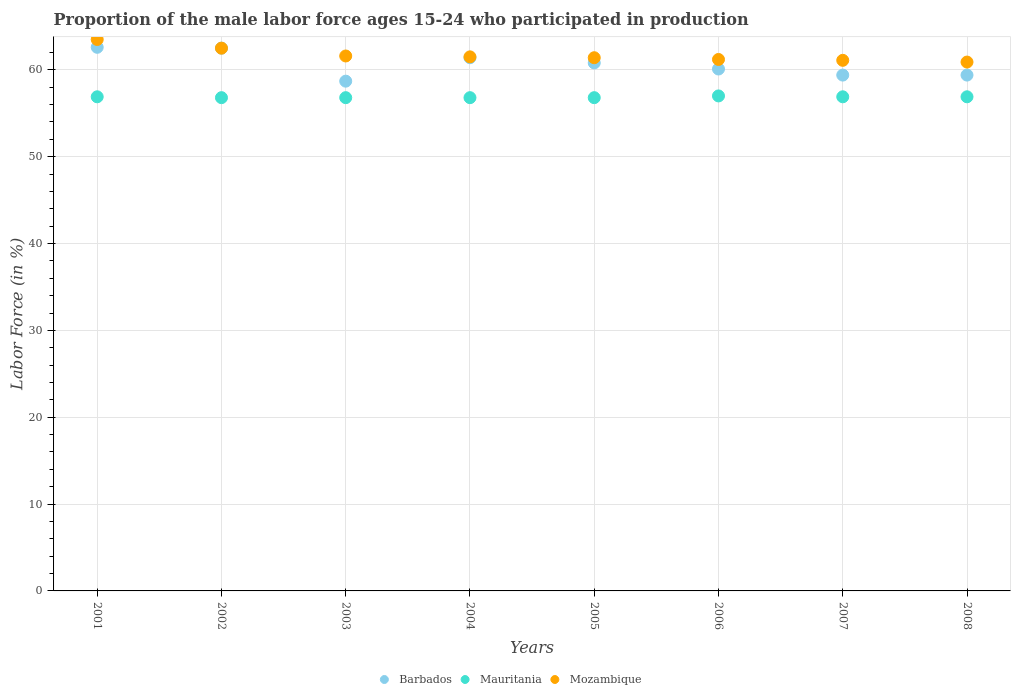Is the number of dotlines equal to the number of legend labels?
Give a very brief answer. Yes. What is the proportion of the male labor force who participated in production in Barbados in 2002?
Offer a very short reply. 62.5. Across all years, what is the maximum proportion of the male labor force who participated in production in Mauritania?
Offer a very short reply. 57. Across all years, what is the minimum proportion of the male labor force who participated in production in Barbados?
Your answer should be compact. 58.7. In which year was the proportion of the male labor force who participated in production in Mozambique maximum?
Provide a succinct answer. 2001. In which year was the proportion of the male labor force who participated in production in Mozambique minimum?
Your answer should be compact. 2008. What is the total proportion of the male labor force who participated in production in Barbados in the graph?
Give a very brief answer. 484.9. What is the difference between the proportion of the male labor force who participated in production in Mauritania in 2003 and that in 2008?
Keep it short and to the point. -0.1. What is the difference between the proportion of the male labor force who participated in production in Mozambique in 2004 and the proportion of the male labor force who participated in production in Mauritania in 2008?
Give a very brief answer. 4.6. What is the average proportion of the male labor force who participated in production in Mauritania per year?
Give a very brief answer. 56.86. In the year 2008, what is the difference between the proportion of the male labor force who participated in production in Barbados and proportion of the male labor force who participated in production in Mauritania?
Provide a short and direct response. 2.5. In how many years, is the proportion of the male labor force who participated in production in Barbados greater than 48 %?
Your answer should be very brief. 8. What is the ratio of the proportion of the male labor force who participated in production in Barbados in 2004 to that in 2006?
Your answer should be very brief. 1.02. Is the proportion of the male labor force who participated in production in Mozambique in 2001 less than that in 2006?
Your answer should be compact. No. Is the difference between the proportion of the male labor force who participated in production in Barbados in 2005 and 2006 greater than the difference between the proportion of the male labor force who participated in production in Mauritania in 2005 and 2006?
Make the answer very short. Yes. What is the difference between the highest and the lowest proportion of the male labor force who participated in production in Barbados?
Your answer should be very brief. 3.9. In how many years, is the proportion of the male labor force who participated in production in Barbados greater than the average proportion of the male labor force who participated in production in Barbados taken over all years?
Your answer should be very brief. 4. Is the sum of the proportion of the male labor force who participated in production in Mozambique in 2002 and 2004 greater than the maximum proportion of the male labor force who participated in production in Barbados across all years?
Make the answer very short. Yes. Is it the case that in every year, the sum of the proportion of the male labor force who participated in production in Mauritania and proportion of the male labor force who participated in production in Mozambique  is greater than the proportion of the male labor force who participated in production in Barbados?
Keep it short and to the point. Yes. Does the proportion of the male labor force who participated in production in Mozambique monotonically increase over the years?
Ensure brevity in your answer.  No. Is the proportion of the male labor force who participated in production in Mauritania strictly less than the proportion of the male labor force who participated in production in Mozambique over the years?
Offer a very short reply. Yes. How many dotlines are there?
Make the answer very short. 3. How many years are there in the graph?
Provide a succinct answer. 8. What is the difference between two consecutive major ticks on the Y-axis?
Provide a succinct answer. 10. Are the values on the major ticks of Y-axis written in scientific E-notation?
Keep it short and to the point. No. Where does the legend appear in the graph?
Give a very brief answer. Bottom center. How many legend labels are there?
Ensure brevity in your answer.  3. What is the title of the graph?
Offer a very short reply. Proportion of the male labor force ages 15-24 who participated in production. Does "Eritrea" appear as one of the legend labels in the graph?
Give a very brief answer. No. What is the label or title of the X-axis?
Keep it short and to the point. Years. What is the label or title of the Y-axis?
Offer a very short reply. Labor Force (in %). What is the Labor Force (in %) of Barbados in 2001?
Offer a terse response. 62.6. What is the Labor Force (in %) in Mauritania in 2001?
Your answer should be very brief. 56.9. What is the Labor Force (in %) of Mozambique in 2001?
Your answer should be very brief. 63.5. What is the Labor Force (in %) of Barbados in 2002?
Ensure brevity in your answer.  62.5. What is the Labor Force (in %) in Mauritania in 2002?
Provide a short and direct response. 56.8. What is the Labor Force (in %) of Mozambique in 2002?
Provide a succinct answer. 62.5. What is the Labor Force (in %) in Barbados in 2003?
Keep it short and to the point. 58.7. What is the Labor Force (in %) of Mauritania in 2003?
Ensure brevity in your answer.  56.8. What is the Labor Force (in %) in Mozambique in 2003?
Keep it short and to the point. 61.6. What is the Labor Force (in %) of Barbados in 2004?
Provide a succinct answer. 61.4. What is the Labor Force (in %) in Mauritania in 2004?
Offer a very short reply. 56.8. What is the Labor Force (in %) of Mozambique in 2004?
Your answer should be compact. 61.5. What is the Labor Force (in %) in Barbados in 2005?
Your answer should be very brief. 60.8. What is the Labor Force (in %) in Mauritania in 2005?
Your response must be concise. 56.8. What is the Labor Force (in %) in Mozambique in 2005?
Ensure brevity in your answer.  61.4. What is the Labor Force (in %) of Barbados in 2006?
Keep it short and to the point. 60.1. What is the Labor Force (in %) of Mauritania in 2006?
Provide a short and direct response. 57. What is the Labor Force (in %) of Mozambique in 2006?
Your answer should be compact. 61.2. What is the Labor Force (in %) in Barbados in 2007?
Your response must be concise. 59.4. What is the Labor Force (in %) in Mauritania in 2007?
Your answer should be compact. 56.9. What is the Labor Force (in %) in Mozambique in 2007?
Your answer should be compact. 61.1. What is the Labor Force (in %) in Barbados in 2008?
Offer a very short reply. 59.4. What is the Labor Force (in %) of Mauritania in 2008?
Your answer should be compact. 56.9. What is the Labor Force (in %) in Mozambique in 2008?
Your response must be concise. 60.9. Across all years, what is the maximum Labor Force (in %) of Barbados?
Offer a terse response. 62.6. Across all years, what is the maximum Labor Force (in %) in Mozambique?
Your response must be concise. 63.5. Across all years, what is the minimum Labor Force (in %) of Barbados?
Provide a short and direct response. 58.7. Across all years, what is the minimum Labor Force (in %) in Mauritania?
Keep it short and to the point. 56.8. Across all years, what is the minimum Labor Force (in %) of Mozambique?
Offer a very short reply. 60.9. What is the total Labor Force (in %) in Barbados in the graph?
Keep it short and to the point. 484.9. What is the total Labor Force (in %) of Mauritania in the graph?
Provide a succinct answer. 454.9. What is the total Labor Force (in %) in Mozambique in the graph?
Your answer should be compact. 493.7. What is the difference between the Labor Force (in %) of Barbados in 2001 and that in 2002?
Offer a terse response. 0.1. What is the difference between the Labor Force (in %) of Mozambique in 2001 and that in 2002?
Provide a short and direct response. 1. What is the difference between the Labor Force (in %) of Barbados in 2001 and that in 2003?
Your response must be concise. 3.9. What is the difference between the Labor Force (in %) of Mauritania in 2001 and that in 2003?
Provide a short and direct response. 0.1. What is the difference between the Labor Force (in %) of Mozambique in 2001 and that in 2003?
Provide a short and direct response. 1.9. What is the difference between the Labor Force (in %) in Barbados in 2001 and that in 2004?
Offer a terse response. 1.2. What is the difference between the Labor Force (in %) in Mauritania in 2001 and that in 2004?
Provide a short and direct response. 0.1. What is the difference between the Labor Force (in %) in Mozambique in 2001 and that in 2004?
Your response must be concise. 2. What is the difference between the Labor Force (in %) of Mozambique in 2001 and that in 2005?
Keep it short and to the point. 2.1. What is the difference between the Labor Force (in %) of Mauritania in 2001 and that in 2006?
Ensure brevity in your answer.  -0.1. What is the difference between the Labor Force (in %) of Barbados in 2001 and that in 2007?
Offer a very short reply. 3.2. What is the difference between the Labor Force (in %) in Mauritania in 2001 and that in 2007?
Provide a short and direct response. 0. What is the difference between the Labor Force (in %) of Mozambique in 2001 and that in 2007?
Keep it short and to the point. 2.4. What is the difference between the Labor Force (in %) in Mauritania in 2001 and that in 2008?
Your response must be concise. 0. What is the difference between the Labor Force (in %) in Barbados in 2002 and that in 2003?
Offer a terse response. 3.8. What is the difference between the Labor Force (in %) in Mauritania in 2002 and that in 2003?
Offer a very short reply. 0. What is the difference between the Labor Force (in %) in Mozambique in 2002 and that in 2003?
Give a very brief answer. 0.9. What is the difference between the Labor Force (in %) in Barbados in 2002 and that in 2004?
Provide a short and direct response. 1.1. What is the difference between the Labor Force (in %) in Mozambique in 2002 and that in 2004?
Give a very brief answer. 1. What is the difference between the Labor Force (in %) of Barbados in 2002 and that in 2005?
Keep it short and to the point. 1.7. What is the difference between the Labor Force (in %) of Mauritania in 2002 and that in 2005?
Your response must be concise. 0. What is the difference between the Labor Force (in %) of Mozambique in 2002 and that in 2005?
Ensure brevity in your answer.  1.1. What is the difference between the Labor Force (in %) of Mauritania in 2002 and that in 2006?
Your response must be concise. -0.2. What is the difference between the Labor Force (in %) in Mozambique in 2002 and that in 2006?
Provide a short and direct response. 1.3. What is the difference between the Labor Force (in %) of Mauritania in 2002 and that in 2007?
Your answer should be compact. -0.1. What is the difference between the Labor Force (in %) of Mauritania in 2002 and that in 2008?
Give a very brief answer. -0.1. What is the difference between the Labor Force (in %) in Mozambique in 2002 and that in 2008?
Ensure brevity in your answer.  1.6. What is the difference between the Labor Force (in %) of Barbados in 2003 and that in 2004?
Offer a terse response. -2.7. What is the difference between the Labor Force (in %) of Barbados in 2003 and that in 2005?
Offer a terse response. -2.1. What is the difference between the Labor Force (in %) of Barbados in 2003 and that in 2007?
Make the answer very short. -0.7. What is the difference between the Labor Force (in %) in Mauritania in 2003 and that in 2007?
Offer a very short reply. -0.1. What is the difference between the Labor Force (in %) of Mozambique in 2003 and that in 2008?
Provide a short and direct response. 0.7. What is the difference between the Labor Force (in %) in Barbados in 2004 and that in 2005?
Keep it short and to the point. 0.6. What is the difference between the Labor Force (in %) in Mauritania in 2004 and that in 2005?
Offer a terse response. 0. What is the difference between the Labor Force (in %) in Mauritania in 2004 and that in 2006?
Offer a very short reply. -0.2. What is the difference between the Labor Force (in %) of Mozambique in 2004 and that in 2006?
Your response must be concise. 0.3. What is the difference between the Labor Force (in %) in Barbados in 2004 and that in 2007?
Provide a succinct answer. 2. What is the difference between the Labor Force (in %) of Mauritania in 2004 and that in 2007?
Your response must be concise. -0.1. What is the difference between the Labor Force (in %) of Mozambique in 2004 and that in 2007?
Your answer should be compact. 0.4. What is the difference between the Labor Force (in %) in Mauritania in 2004 and that in 2008?
Keep it short and to the point. -0.1. What is the difference between the Labor Force (in %) of Mozambique in 2004 and that in 2008?
Your answer should be compact. 0.6. What is the difference between the Labor Force (in %) in Mauritania in 2005 and that in 2006?
Provide a succinct answer. -0.2. What is the difference between the Labor Force (in %) in Barbados in 2005 and that in 2007?
Give a very brief answer. 1.4. What is the difference between the Labor Force (in %) in Mauritania in 2005 and that in 2007?
Keep it short and to the point. -0.1. What is the difference between the Labor Force (in %) of Barbados in 2006 and that in 2007?
Offer a terse response. 0.7. What is the difference between the Labor Force (in %) of Barbados in 2006 and that in 2008?
Provide a succinct answer. 0.7. What is the difference between the Labor Force (in %) in Mauritania in 2006 and that in 2008?
Provide a short and direct response. 0.1. What is the difference between the Labor Force (in %) of Mozambique in 2006 and that in 2008?
Your answer should be very brief. 0.3. What is the difference between the Labor Force (in %) of Mauritania in 2007 and that in 2008?
Keep it short and to the point. 0. What is the difference between the Labor Force (in %) of Mozambique in 2007 and that in 2008?
Provide a succinct answer. 0.2. What is the difference between the Labor Force (in %) of Mauritania in 2001 and the Labor Force (in %) of Mozambique in 2002?
Ensure brevity in your answer.  -5.6. What is the difference between the Labor Force (in %) in Barbados in 2001 and the Labor Force (in %) in Mauritania in 2004?
Your answer should be compact. 5.8. What is the difference between the Labor Force (in %) of Barbados in 2001 and the Labor Force (in %) of Mozambique in 2004?
Your answer should be very brief. 1.1. What is the difference between the Labor Force (in %) in Barbados in 2001 and the Labor Force (in %) in Mauritania in 2005?
Make the answer very short. 5.8. What is the difference between the Labor Force (in %) in Mauritania in 2001 and the Labor Force (in %) in Mozambique in 2005?
Give a very brief answer. -4.5. What is the difference between the Labor Force (in %) of Barbados in 2001 and the Labor Force (in %) of Mauritania in 2006?
Offer a very short reply. 5.6. What is the difference between the Labor Force (in %) in Barbados in 2001 and the Labor Force (in %) in Mozambique in 2006?
Ensure brevity in your answer.  1.4. What is the difference between the Labor Force (in %) of Barbados in 2001 and the Labor Force (in %) of Mauritania in 2007?
Make the answer very short. 5.7. What is the difference between the Labor Force (in %) in Mauritania in 2001 and the Labor Force (in %) in Mozambique in 2007?
Your answer should be compact. -4.2. What is the difference between the Labor Force (in %) of Barbados in 2001 and the Labor Force (in %) of Mauritania in 2008?
Offer a very short reply. 5.7. What is the difference between the Labor Force (in %) of Barbados in 2001 and the Labor Force (in %) of Mozambique in 2008?
Provide a succinct answer. 1.7. What is the difference between the Labor Force (in %) of Barbados in 2002 and the Labor Force (in %) of Mauritania in 2003?
Keep it short and to the point. 5.7. What is the difference between the Labor Force (in %) of Barbados in 2002 and the Labor Force (in %) of Mozambique in 2003?
Your answer should be very brief. 0.9. What is the difference between the Labor Force (in %) in Mauritania in 2002 and the Labor Force (in %) in Mozambique in 2003?
Ensure brevity in your answer.  -4.8. What is the difference between the Labor Force (in %) of Barbados in 2002 and the Labor Force (in %) of Mozambique in 2004?
Your answer should be compact. 1. What is the difference between the Labor Force (in %) of Mauritania in 2002 and the Labor Force (in %) of Mozambique in 2004?
Give a very brief answer. -4.7. What is the difference between the Labor Force (in %) in Mauritania in 2002 and the Labor Force (in %) in Mozambique in 2005?
Your answer should be very brief. -4.6. What is the difference between the Labor Force (in %) of Barbados in 2002 and the Labor Force (in %) of Mauritania in 2006?
Make the answer very short. 5.5. What is the difference between the Labor Force (in %) in Barbados in 2002 and the Labor Force (in %) in Mozambique in 2006?
Offer a terse response. 1.3. What is the difference between the Labor Force (in %) of Mauritania in 2002 and the Labor Force (in %) of Mozambique in 2006?
Provide a succinct answer. -4.4. What is the difference between the Labor Force (in %) in Barbados in 2002 and the Labor Force (in %) in Mauritania in 2007?
Your response must be concise. 5.6. What is the difference between the Labor Force (in %) in Barbados in 2002 and the Labor Force (in %) in Mozambique in 2007?
Provide a succinct answer. 1.4. What is the difference between the Labor Force (in %) of Mauritania in 2002 and the Labor Force (in %) of Mozambique in 2007?
Provide a succinct answer. -4.3. What is the difference between the Labor Force (in %) of Barbados in 2002 and the Labor Force (in %) of Mauritania in 2008?
Provide a succinct answer. 5.6. What is the difference between the Labor Force (in %) of Barbados in 2002 and the Labor Force (in %) of Mozambique in 2008?
Keep it short and to the point. 1.6. What is the difference between the Labor Force (in %) in Mauritania in 2002 and the Labor Force (in %) in Mozambique in 2008?
Offer a terse response. -4.1. What is the difference between the Labor Force (in %) in Barbados in 2003 and the Labor Force (in %) in Mauritania in 2004?
Give a very brief answer. 1.9. What is the difference between the Labor Force (in %) in Barbados in 2003 and the Labor Force (in %) in Mozambique in 2004?
Ensure brevity in your answer.  -2.8. What is the difference between the Labor Force (in %) in Barbados in 2003 and the Labor Force (in %) in Mauritania in 2005?
Keep it short and to the point. 1.9. What is the difference between the Labor Force (in %) of Mauritania in 2003 and the Labor Force (in %) of Mozambique in 2005?
Provide a succinct answer. -4.6. What is the difference between the Labor Force (in %) of Barbados in 2003 and the Labor Force (in %) of Mauritania in 2007?
Your answer should be very brief. 1.8. What is the difference between the Labor Force (in %) of Barbados in 2003 and the Labor Force (in %) of Mozambique in 2007?
Offer a terse response. -2.4. What is the difference between the Labor Force (in %) of Mauritania in 2003 and the Labor Force (in %) of Mozambique in 2007?
Give a very brief answer. -4.3. What is the difference between the Labor Force (in %) in Barbados in 2003 and the Labor Force (in %) in Mauritania in 2008?
Your answer should be very brief. 1.8. What is the difference between the Labor Force (in %) of Barbados in 2003 and the Labor Force (in %) of Mozambique in 2008?
Your answer should be very brief. -2.2. What is the difference between the Labor Force (in %) of Barbados in 2004 and the Labor Force (in %) of Mauritania in 2005?
Your answer should be compact. 4.6. What is the difference between the Labor Force (in %) in Barbados in 2004 and the Labor Force (in %) in Mozambique in 2005?
Give a very brief answer. 0. What is the difference between the Labor Force (in %) in Mauritania in 2004 and the Labor Force (in %) in Mozambique in 2005?
Offer a very short reply. -4.6. What is the difference between the Labor Force (in %) of Mauritania in 2004 and the Labor Force (in %) of Mozambique in 2006?
Keep it short and to the point. -4.4. What is the difference between the Labor Force (in %) in Barbados in 2004 and the Labor Force (in %) in Mauritania in 2007?
Your answer should be compact. 4.5. What is the difference between the Labor Force (in %) of Barbados in 2004 and the Labor Force (in %) of Mozambique in 2007?
Your answer should be compact. 0.3. What is the difference between the Labor Force (in %) in Mauritania in 2004 and the Labor Force (in %) in Mozambique in 2007?
Provide a succinct answer. -4.3. What is the difference between the Labor Force (in %) in Barbados in 2004 and the Labor Force (in %) in Mauritania in 2008?
Your response must be concise. 4.5. What is the difference between the Labor Force (in %) in Barbados in 2004 and the Labor Force (in %) in Mozambique in 2008?
Offer a terse response. 0.5. What is the difference between the Labor Force (in %) of Mauritania in 2004 and the Labor Force (in %) of Mozambique in 2008?
Offer a very short reply. -4.1. What is the difference between the Labor Force (in %) of Barbados in 2005 and the Labor Force (in %) of Mauritania in 2006?
Your response must be concise. 3.8. What is the difference between the Labor Force (in %) of Barbados in 2005 and the Labor Force (in %) of Mozambique in 2007?
Provide a succinct answer. -0.3. What is the difference between the Labor Force (in %) of Barbados in 2005 and the Labor Force (in %) of Mozambique in 2008?
Offer a terse response. -0.1. What is the difference between the Labor Force (in %) of Barbados in 2006 and the Labor Force (in %) of Mauritania in 2007?
Provide a succinct answer. 3.2. What is the difference between the Labor Force (in %) of Mauritania in 2006 and the Labor Force (in %) of Mozambique in 2008?
Give a very brief answer. -3.9. What is the average Labor Force (in %) of Barbados per year?
Offer a terse response. 60.61. What is the average Labor Force (in %) in Mauritania per year?
Provide a succinct answer. 56.86. What is the average Labor Force (in %) in Mozambique per year?
Your answer should be compact. 61.71. In the year 2001, what is the difference between the Labor Force (in %) of Barbados and Labor Force (in %) of Mauritania?
Your answer should be very brief. 5.7. In the year 2002, what is the difference between the Labor Force (in %) of Barbados and Labor Force (in %) of Mauritania?
Provide a succinct answer. 5.7. In the year 2002, what is the difference between the Labor Force (in %) of Mauritania and Labor Force (in %) of Mozambique?
Your answer should be very brief. -5.7. In the year 2003, what is the difference between the Labor Force (in %) in Barbados and Labor Force (in %) in Mauritania?
Offer a very short reply. 1.9. In the year 2003, what is the difference between the Labor Force (in %) in Barbados and Labor Force (in %) in Mozambique?
Your answer should be compact. -2.9. In the year 2003, what is the difference between the Labor Force (in %) in Mauritania and Labor Force (in %) in Mozambique?
Make the answer very short. -4.8. In the year 2006, what is the difference between the Labor Force (in %) of Barbados and Labor Force (in %) of Mauritania?
Give a very brief answer. 3.1. In the year 2006, what is the difference between the Labor Force (in %) of Mauritania and Labor Force (in %) of Mozambique?
Your answer should be compact. -4.2. In the year 2007, what is the difference between the Labor Force (in %) of Mauritania and Labor Force (in %) of Mozambique?
Keep it short and to the point. -4.2. In the year 2008, what is the difference between the Labor Force (in %) of Barbados and Labor Force (in %) of Mozambique?
Offer a terse response. -1.5. In the year 2008, what is the difference between the Labor Force (in %) in Mauritania and Labor Force (in %) in Mozambique?
Ensure brevity in your answer.  -4. What is the ratio of the Labor Force (in %) in Mozambique in 2001 to that in 2002?
Provide a succinct answer. 1.02. What is the ratio of the Labor Force (in %) in Barbados in 2001 to that in 2003?
Ensure brevity in your answer.  1.07. What is the ratio of the Labor Force (in %) of Mozambique in 2001 to that in 2003?
Your response must be concise. 1.03. What is the ratio of the Labor Force (in %) in Barbados in 2001 to that in 2004?
Your answer should be very brief. 1.02. What is the ratio of the Labor Force (in %) of Mozambique in 2001 to that in 2004?
Make the answer very short. 1.03. What is the ratio of the Labor Force (in %) in Barbados in 2001 to that in 2005?
Make the answer very short. 1.03. What is the ratio of the Labor Force (in %) in Mozambique in 2001 to that in 2005?
Your answer should be very brief. 1.03. What is the ratio of the Labor Force (in %) of Barbados in 2001 to that in 2006?
Keep it short and to the point. 1.04. What is the ratio of the Labor Force (in %) of Mauritania in 2001 to that in 2006?
Your answer should be compact. 1. What is the ratio of the Labor Force (in %) in Mozambique in 2001 to that in 2006?
Offer a terse response. 1.04. What is the ratio of the Labor Force (in %) in Barbados in 2001 to that in 2007?
Your answer should be compact. 1.05. What is the ratio of the Labor Force (in %) of Mozambique in 2001 to that in 2007?
Provide a short and direct response. 1.04. What is the ratio of the Labor Force (in %) of Barbados in 2001 to that in 2008?
Ensure brevity in your answer.  1.05. What is the ratio of the Labor Force (in %) of Mozambique in 2001 to that in 2008?
Your answer should be compact. 1.04. What is the ratio of the Labor Force (in %) in Barbados in 2002 to that in 2003?
Provide a succinct answer. 1.06. What is the ratio of the Labor Force (in %) of Mozambique in 2002 to that in 2003?
Provide a succinct answer. 1.01. What is the ratio of the Labor Force (in %) in Barbados in 2002 to that in 2004?
Keep it short and to the point. 1.02. What is the ratio of the Labor Force (in %) in Mozambique in 2002 to that in 2004?
Your response must be concise. 1.02. What is the ratio of the Labor Force (in %) in Barbados in 2002 to that in 2005?
Provide a short and direct response. 1.03. What is the ratio of the Labor Force (in %) of Mozambique in 2002 to that in 2005?
Give a very brief answer. 1.02. What is the ratio of the Labor Force (in %) in Barbados in 2002 to that in 2006?
Your answer should be compact. 1.04. What is the ratio of the Labor Force (in %) of Mozambique in 2002 to that in 2006?
Offer a very short reply. 1.02. What is the ratio of the Labor Force (in %) of Barbados in 2002 to that in 2007?
Offer a very short reply. 1.05. What is the ratio of the Labor Force (in %) in Mauritania in 2002 to that in 2007?
Your answer should be compact. 1. What is the ratio of the Labor Force (in %) in Mozambique in 2002 to that in 2007?
Offer a terse response. 1.02. What is the ratio of the Labor Force (in %) in Barbados in 2002 to that in 2008?
Make the answer very short. 1.05. What is the ratio of the Labor Force (in %) of Mauritania in 2002 to that in 2008?
Offer a terse response. 1. What is the ratio of the Labor Force (in %) of Mozambique in 2002 to that in 2008?
Ensure brevity in your answer.  1.03. What is the ratio of the Labor Force (in %) of Barbados in 2003 to that in 2004?
Offer a terse response. 0.96. What is the ratio of the Labor Force (in %) of Barbados in 2003 to that in 2005?
Your answer should be very brief. 0.97. What is the ratio of the Labor Force (in %) in Barbados in 2003 to that in 2006?
Your response must be concise. 0.98. What is the ratio of the Labor Force (in %) of Mozambique in 2003 to that in 2006?
Ensure brevity in your answer.  1.01. What is the ratio of the Labor Force (in %) in Barbados in 2003 to that in 2007?
Your answer should be compact. 0.99. What is the ratio of the Labor Force (in %) in Mauritania in 2003 to that in 2007?
Your response must be concise. 1. What is the ratio of the Labor Force (in %) in Mozambique in 2003 to that in 2007?
Make the answer very short. 1.01. What is the ratio of the Labor Force (in %) in Barbados in 2003 to that in 2008?
Make the answer very short. 0.99. What is the ratio of the Labor Force (in %) of Mozambique in 2003 to that in 2008?
Give a very brief answer. 1.01. What is the ratio of the Labor Force (in %) of Barbados in 2004 to that in 2005?
Provide a succinct answer. 1.01. What is the ratio of the Labor Force (in %) of Barbados in 2004 to that in 2006?
Your answer should be very brief. 1.02. What is the ratio of the Labor Force (in %) in Mozambique in 2004 to that in 2006?
Provide a short and direct response. 1. What is the ratio of the Labor Force (in %) in Barbados in 2004 to that in 2007?
Offer a terse response. 1.03. What is the ratio of the Labor Force (in %) of Mauritania in 2004 to that in 2007?
Ensure brevity in your answer.  1. What is the ratio of the Labor Force (in %) of Barbados in 2004 to that in 2008?
Your response must be concise. 1.03. What is the ratio of the Labor Force (in %) of Mozambique in 2004 to that in 2008?
Make the answer very short. 1.01. What is the ratio of the Labor Force (in %) in Barbados in 2005 to that in 2006?
Offer a terse response. 1.01. What is the ratio of the Labor Force (in %) of Barbados in 2005 to that in 2007?
Ensure brevity in your answer.  1.02. What is the ratio of the Labor Force (in %) in Mozambique in 2005 to that in 2007?
Offer a terse response. 1. What is the ratio of the Labor Force (in %) in Barbados in 2005 to that in 2008?
Your response must be concise. 1.02. What is the ratio of the Labor Force (in %) of Mozambique in 2005 to that in 2008?
Make the answer very short. 1.01. What is the ratio of the Labor Force (in %) in Barbados in 2006 to that in 2007?
Make the answer very short. 1.01. What is the ratio of the Labor Force (in %) in Barbados in 2006 to that in 2008?
Your response must be concise. 1.01. What is the ratio of the Labor Force (in %) in Mauritania in 2006 to that in 2008?
Provide a succinct answer. 1. What is the ratio of the Labor Force (in %) of Mozambique in 2006 to that in 2008?
Your response must be concise. 1. What is the ratio of the Labor Force (in %) of Mauritania in 2007 to that in 2008?
Offer a very short reply. 1. What is the difference between the highest and the lowest Labor Force (in %) in Barbados?
Your answer should be very brief. 3.9. What is the difference between the highest and the lowest Labor Force (in %) in Mozambique?
Your answer should be compact. 2.6. 